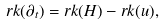<formula> <loc_0><loc_0><loc_500><loc_500>r k ( \partial _ { t } ) = r k ( H ) - r k ( u ) ,</formula> 